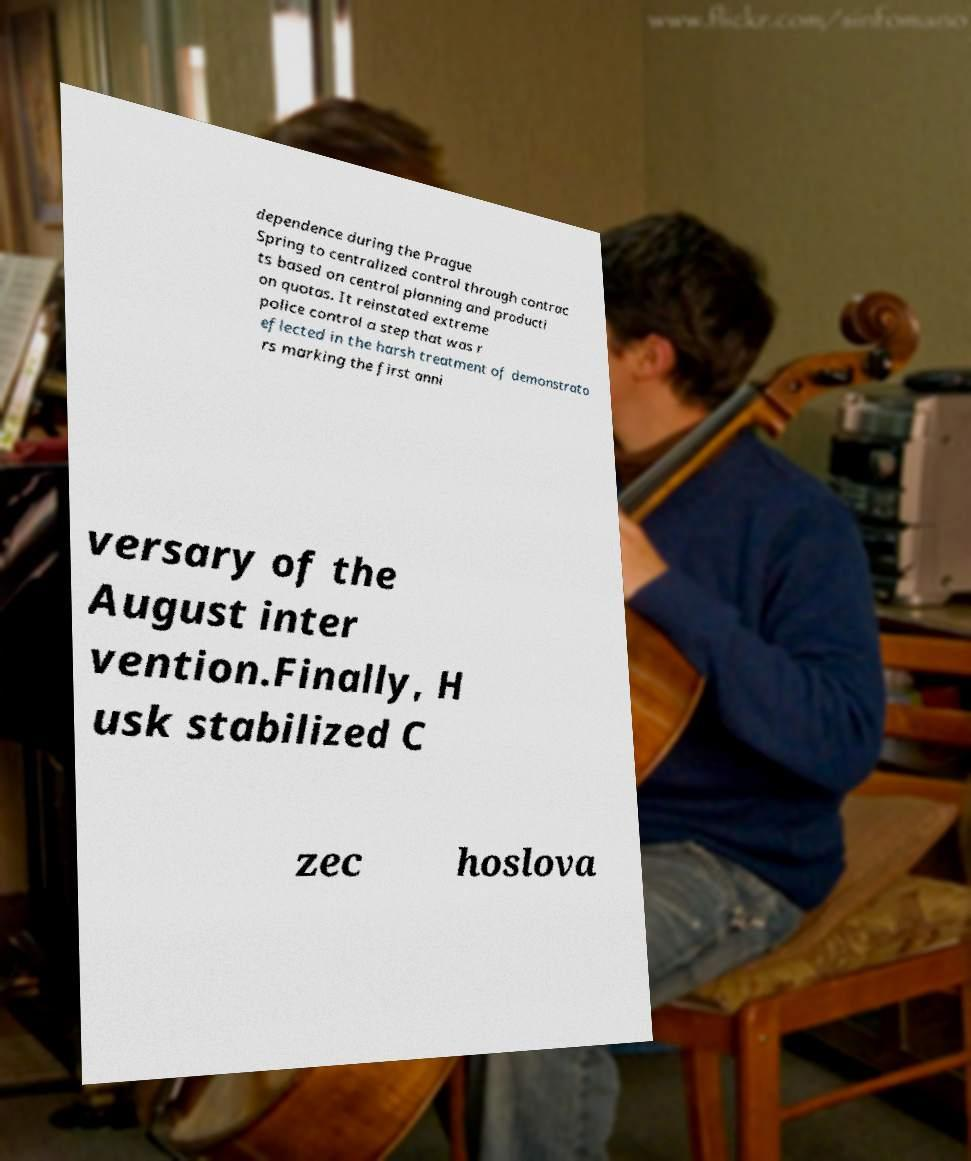Could you assist in decoding the text presented in this image and type it out clearly? dependence during the Prague Spring to centralized control through contrac ts based on central planning and producti on quotas. It reinstated extreme police control a step that was r eflected in the harsh treatment of demonstrato rs marking the first anni versary of the August inter vention.Finally, H usk stabilized C zec hoslova 